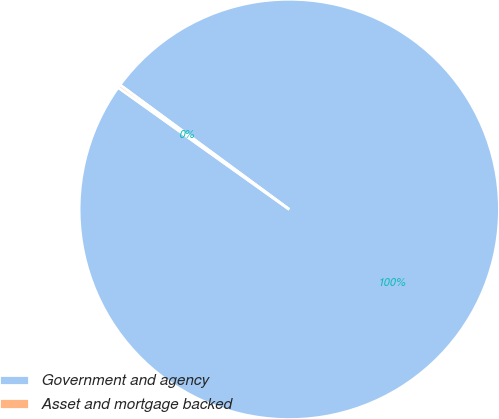<chart> <loc_0><loc_0><loc_500><loc_500><pie_chart><fcel>Government and agency<fcel>Asset and mortgage backed<nl><fcel>99.76%<fcel>0.24%<nl></chart> 